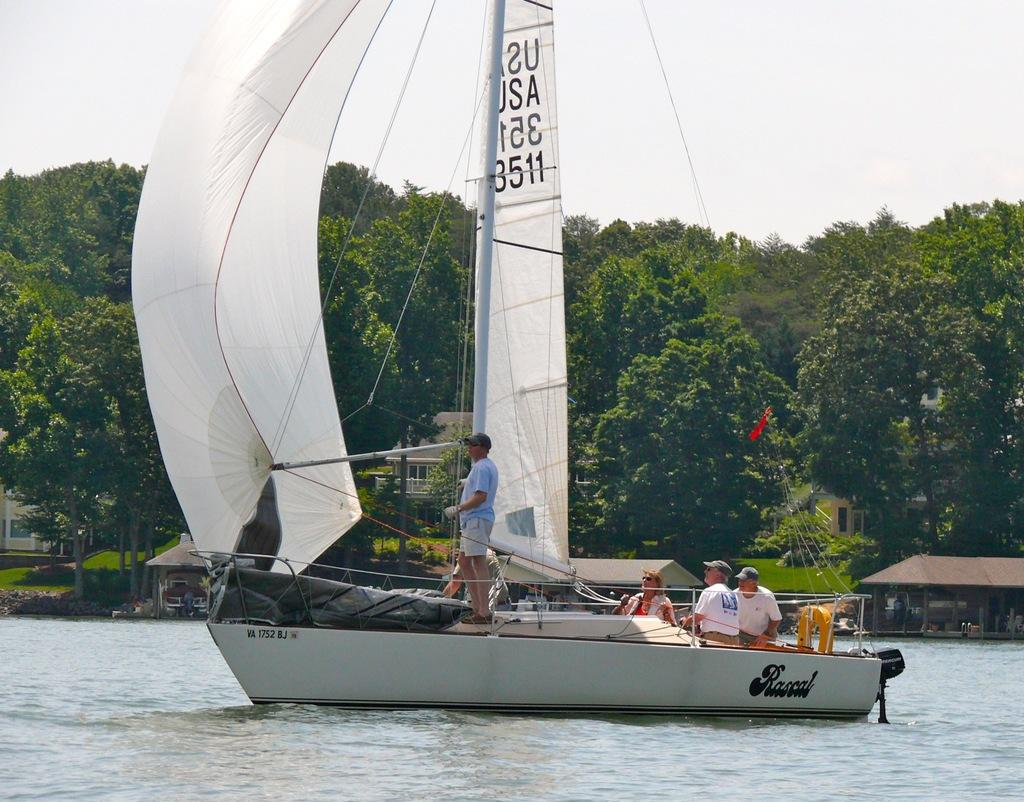What are the people in the image doing? The people in the image are on a boat. What is the primary setting of the image? There is water visible in the image. What type of structures can be seen in the image? There are houses in the image. What type of vegetation is present in the image? Grass, plants, and trees are visible in the image. What is visible in the background of the image? The sky is visible in the background of the image. What type of punishment is being given to the plants in the image? There is no punishment being given to the plants in the image; they are simply visible in the image. How many plants are jumping in the image? There are no plants jumping in the image; plants do not have the ability to jump. 